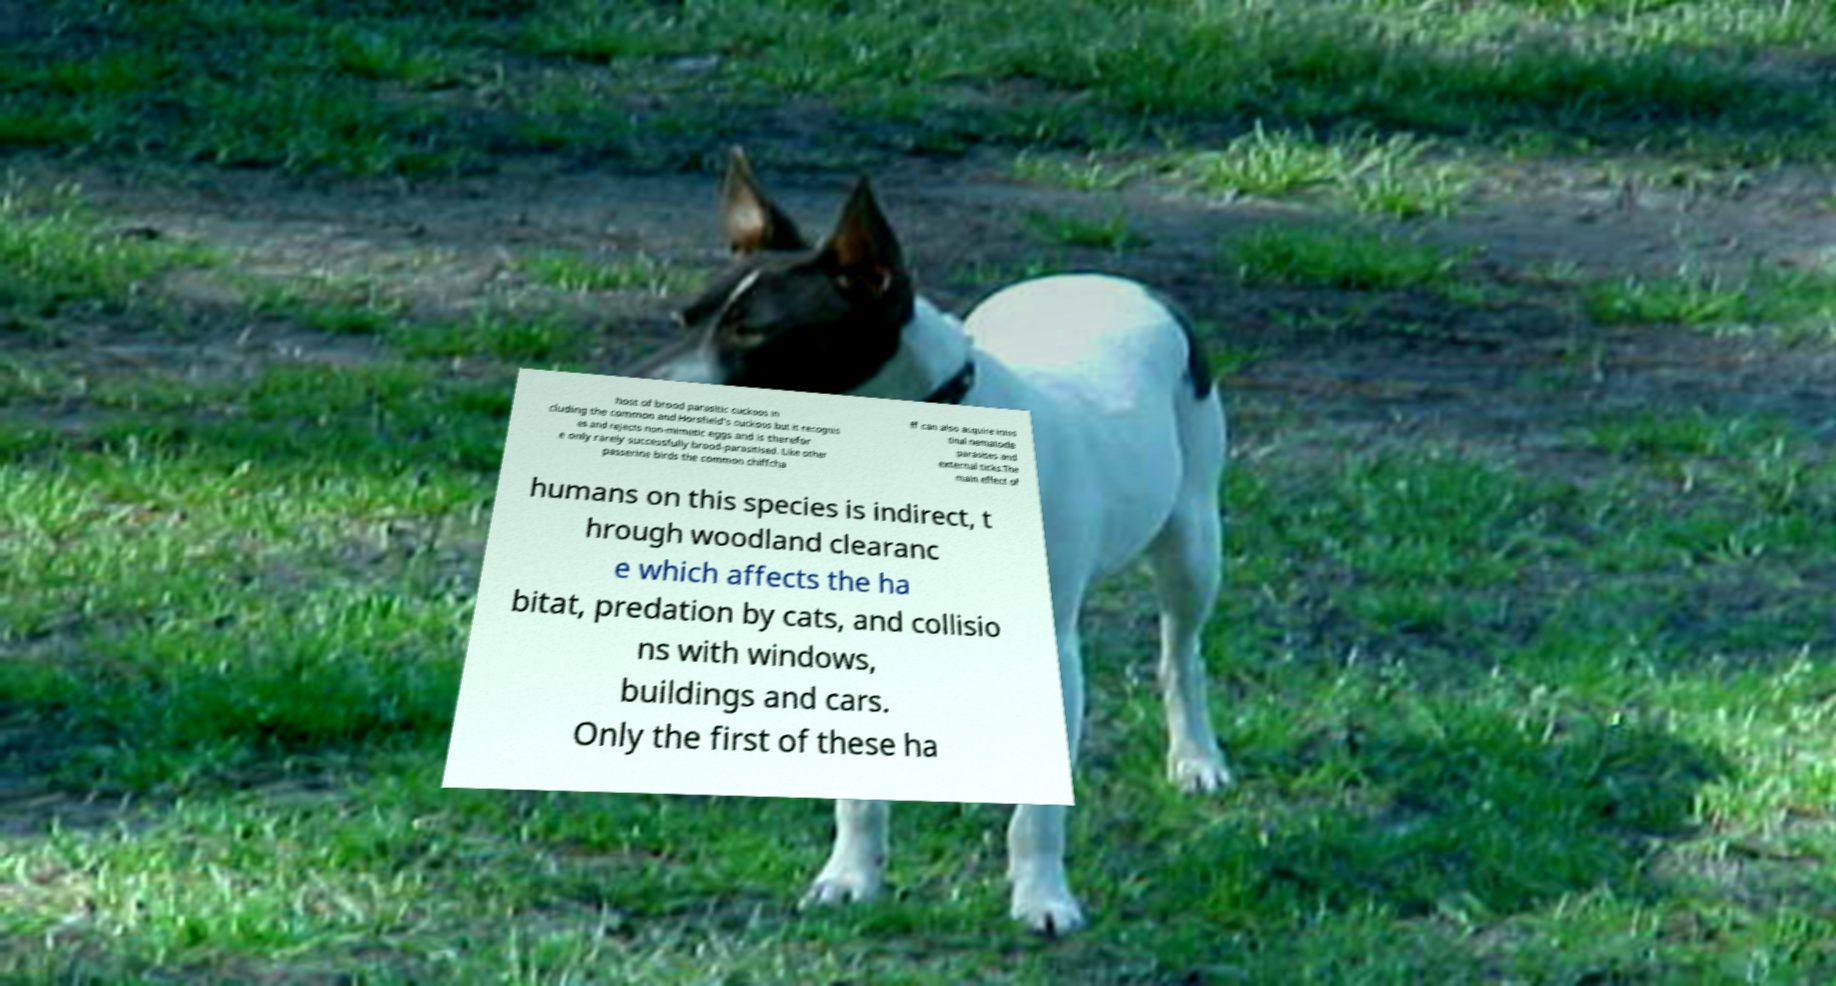Can you accurately transcribe the text from the provided image for me? host of brood parasitic cuckoos in cluding the common and Horsfield's cuckoos but it recognis es and rejects non-mimetic eggs and is therefor e only rarely successfully brood-parasitised. Like other passerine birds the common chiffcha ff can also acquire intes tinal nematode parasites and external ticks.The main effect of humans on this species is indirect, t hrough woodland clearanc e which affects the ha bitat, predation by cats, and collisio ns with windows, buildings and cars. Only the first of these ha 